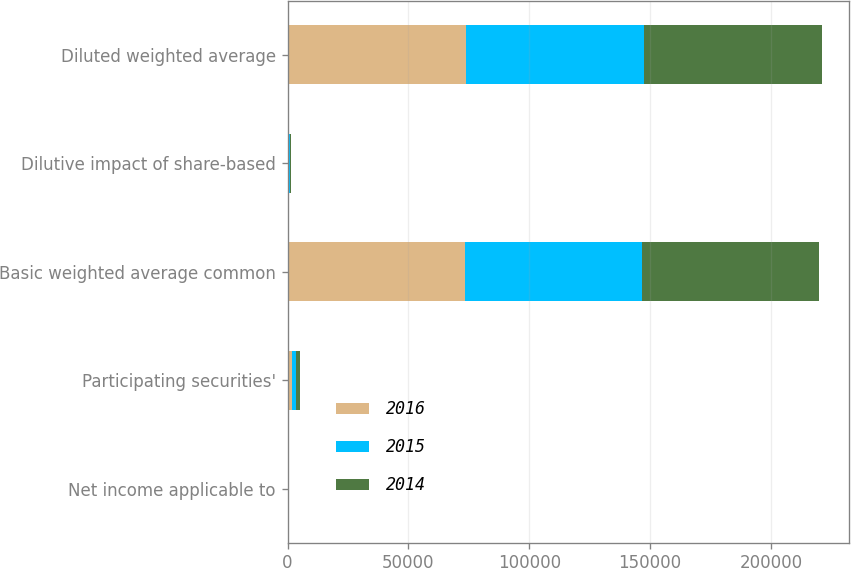Convert chart. <chart><loc_0><loc_0><loc_500><loc_500><stacked_bar_chart><ecel><fcel>Net income applicable to<fcel>Participating securities'<fcel>Basic weighted average common<fcel>Dilutive impact of share-based<fcel>Diluted weighted average<nl><fcel>2016<fcel>6.22<fcel>1945<fcel>73562<fcel>294<fcel>73856<nl><fcel>2015<fcel>6.45<fcel>1653<fcel>73190<fcel>543<fcel>73733<nl><fcel>2014<fcel>6.75<fcel>1555<fcel>72932<fcel>482<fcel>73414<nl></chart> 